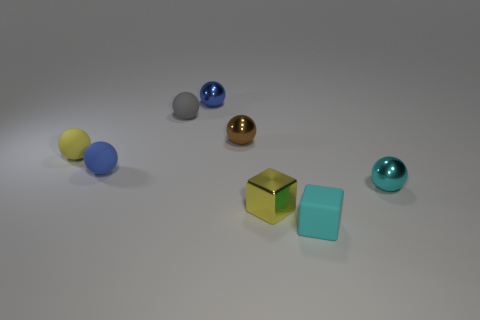Subtract all cyan metallic spheres. How many spheres are left? 5 Subtract all yellow spheres. How many spheres are left? 5 Subtract all spheres. How many objects are left? 2 Add 4 small shiny blocks. How many small shiny blocks exist? 5 Add 2 gray objects. How many objects exist? 10 Subtract 0 purple spheres. How many objects are left? 8 Subtract 3 balls. How many balls are left? 3 Subtract all red balls. Subtract all red cylinders. How many balls are left? 6 Subtract all yellow spheres. How many cyan cubes are left? 1 Subtract all tiny gray rubber objects. Subtract all tiny gray rubber objects. How many objects are left? 6 